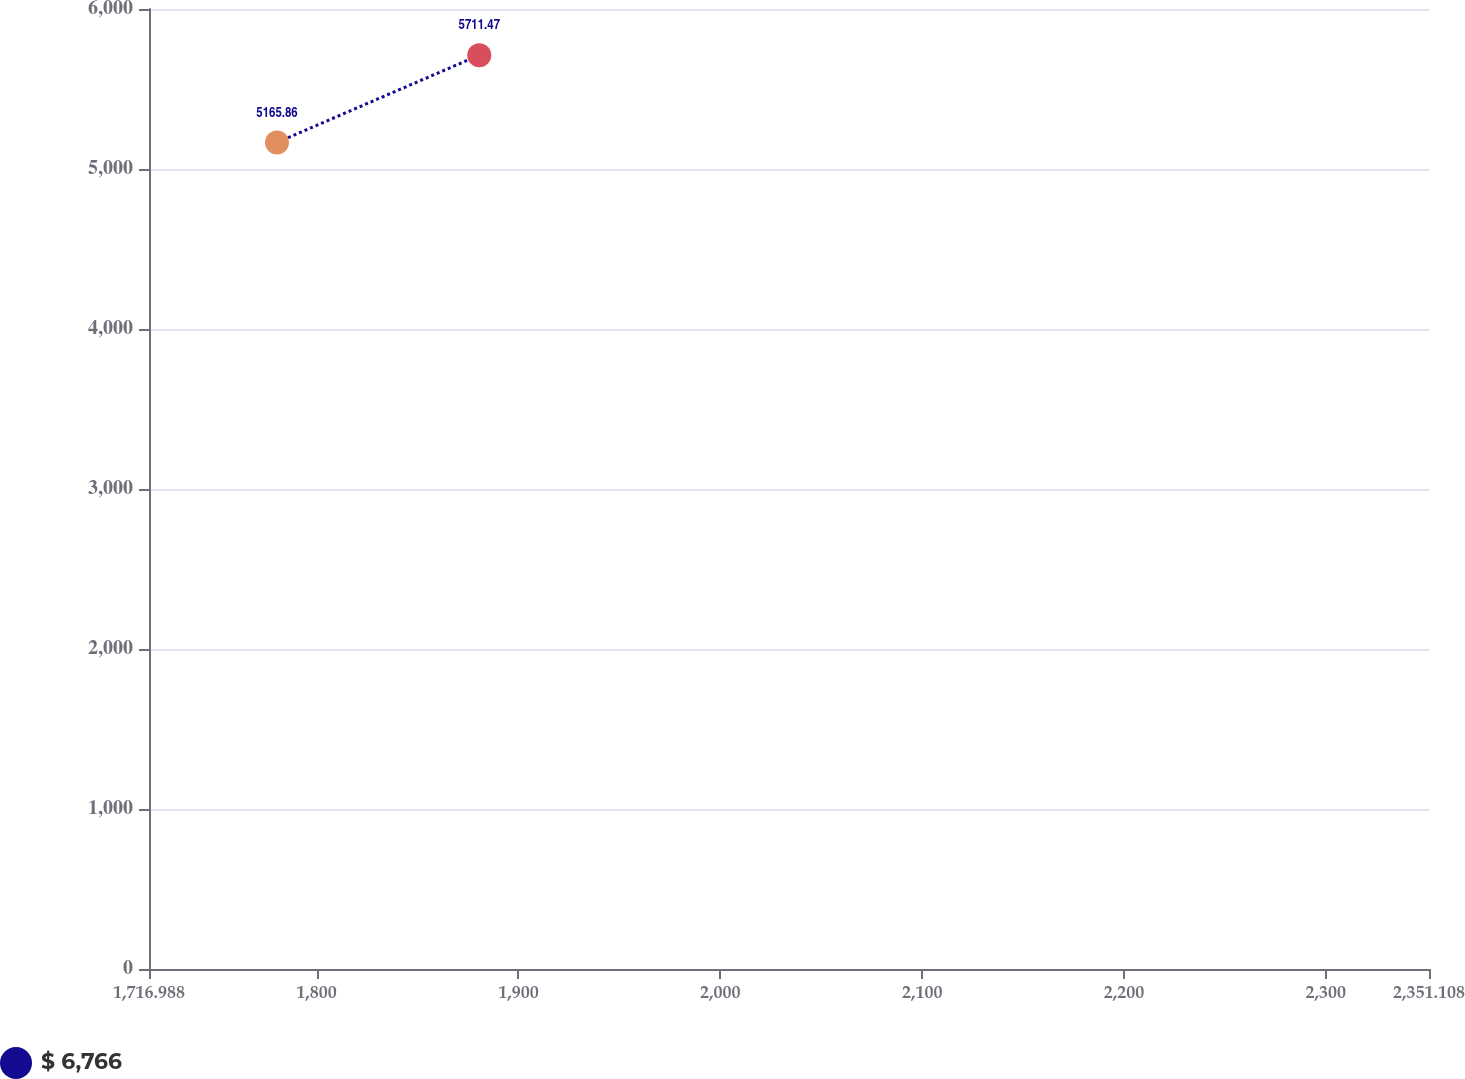Convert chart to OTSL. <chart><loc_0><loc_0><loc_500><loc_500><line_chart><ecel><fcel>$ 6,766<nl><fcel>1780.4<fcel>5165.86<nl><fcel>1880.61<fcel>5711.47<nl><fcel>2356.79<fcel>3670.85<nl><fcel>2414.52<fcel>3874.91<nl></chart> 